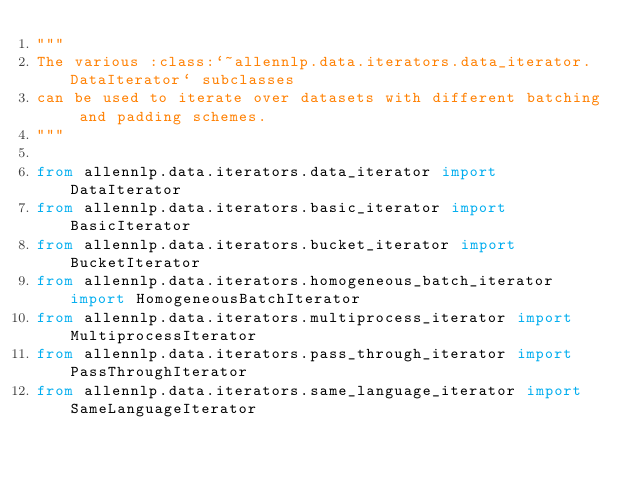Convert code to text. <code><loc_0><loc_0><loc_500><loc_500><_Python_>"""
The various :class:`~allennlp.data.iterators.data_iterator.DataIterator` subclasses
can be used to iterate over datasets with different batching and padding schemes.
"""

from allennlp.data.iterators.data_iterator import DataIterator
from allennlp.data.iterators.basic_iterator import BasicIterator
from allennlp.data.iterators.bucket_iterator import BucketIterator
from allennlp.data.iterators.homogeneous_batch_iterator import HomogeneousBatchIterator
from allennlp.data.iterators.multiprocess_iterator import MultiprocessIterator
from allennlp.data.iterators.pass_through_iterator import PassThroughIterator
from allennlp.data.iterators.same_language_iterator import SameLanguageIterator
</code> 